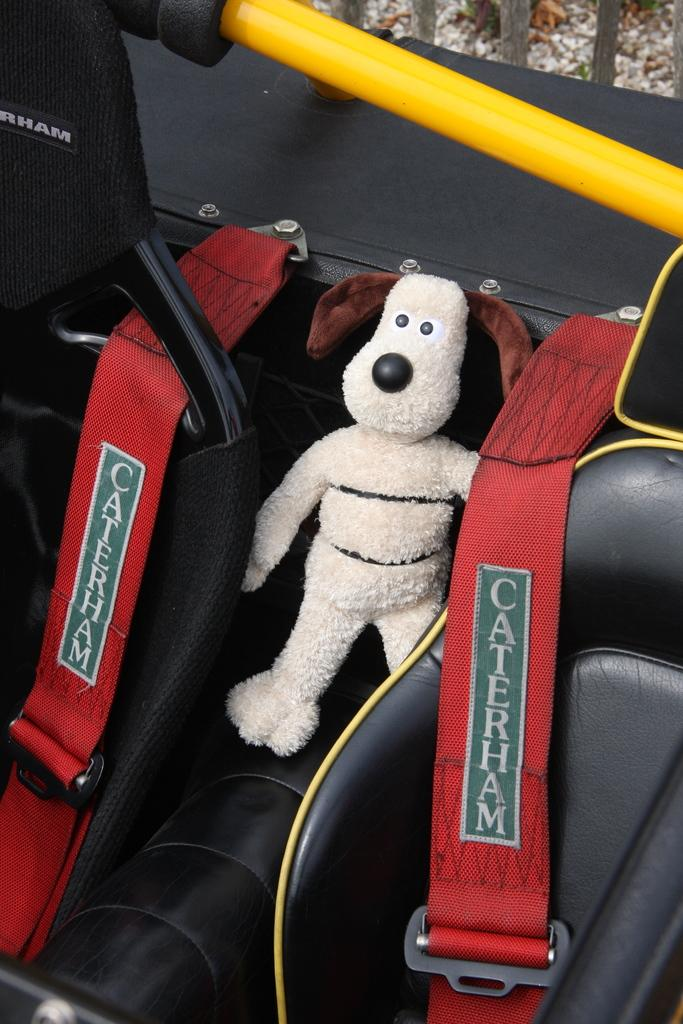What type of furniture is present in the image? There are chairs in the image. What other object can be seen in the image? There is a soft toy in the image. What safety feature is visible in the image? Seat belts are visible in the image. What is written on the seat belts? There is text on the seat belts. Where is the bag placed in the image? There is no bag present in the image. Is the baby sitting on the soft toy in the image? There is no baby present in the image. 